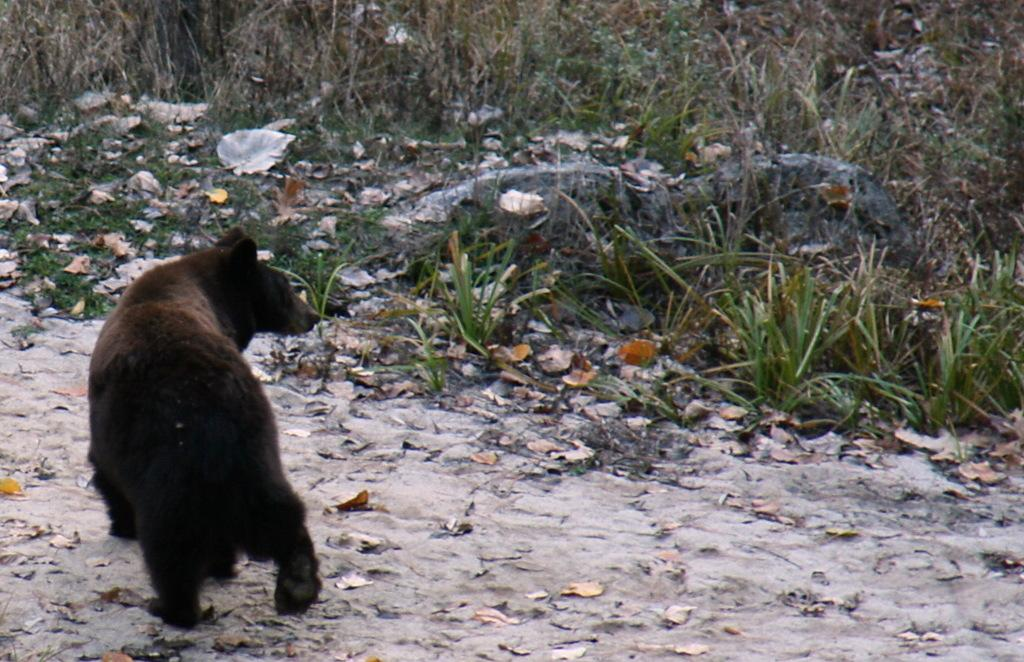What type of animal is in the image? The animal in the image has brown and black colors. What is the background of the image? There is green grass visible in the image. What other natural elements can be seen in the image? There are leaves, sand, and stones visible in the image. What message is written on the sign in the image? There is no sign present in the image. How many noses can be seen on the animal in the image? The animal in the image does not have a nose, as it is not a mammal. 